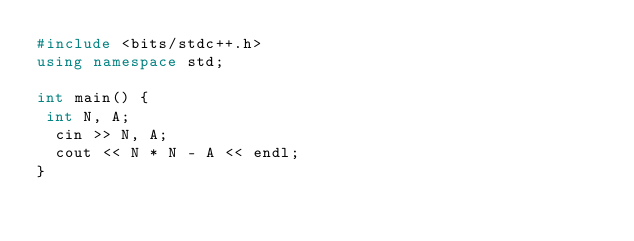Convert code to text. <code><loc_0><loc_0><loc_500><loc_500><_C++_>#include <bits/stdc++.h>
using namespace std;
 
int main() {
 int N, A;
  cin >> N, A;
  cout << N * N - A << endl;  
}</code> 